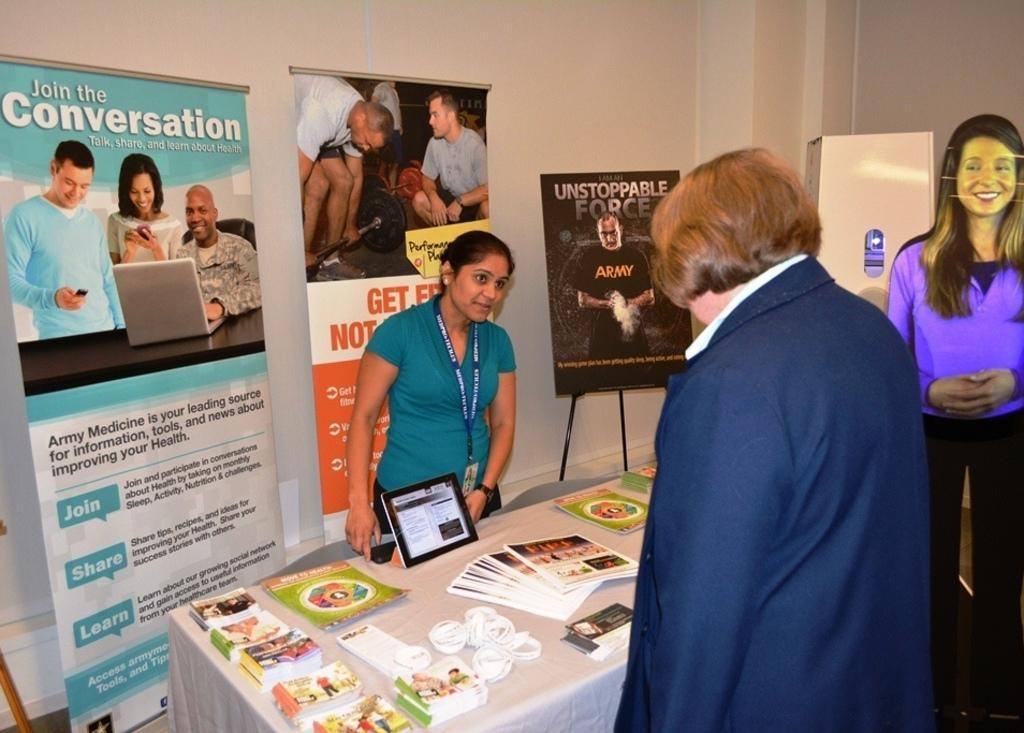Can you describe this image briefly? On the left side, there is a woman in a t-shirt, wearing a badge and standing in front of a table, on which there are posters, a tab, books and other objects. Behind her, there are three posters arranged. On the right side, there is a person in a suit, standing. Beside this person, there is a woman in a blue color t-shirt, smiling and standing. In the background, there is a white color object and there is a wall. 